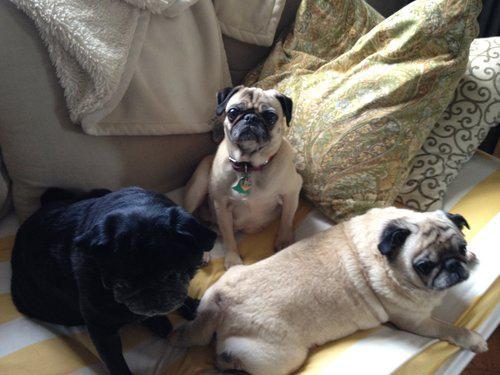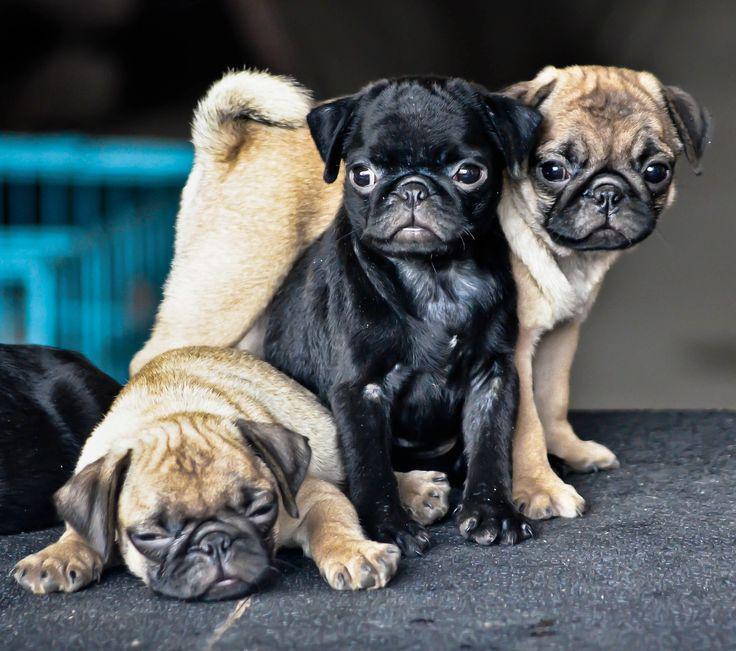The first image is the image on the left, the second image is the image on the right. Given the left and right images, does the statement "The dogs in the image on the right are wearing winter coats." hold true? Answer yes or no. No. The first image is the image on the left, the second image is the image on the right. Evaluate the accuracy of this statement regarding the images: "Three pugs are posed in a row wearing outfits with fur collars.". Is it true? Answer yes or no. No. 